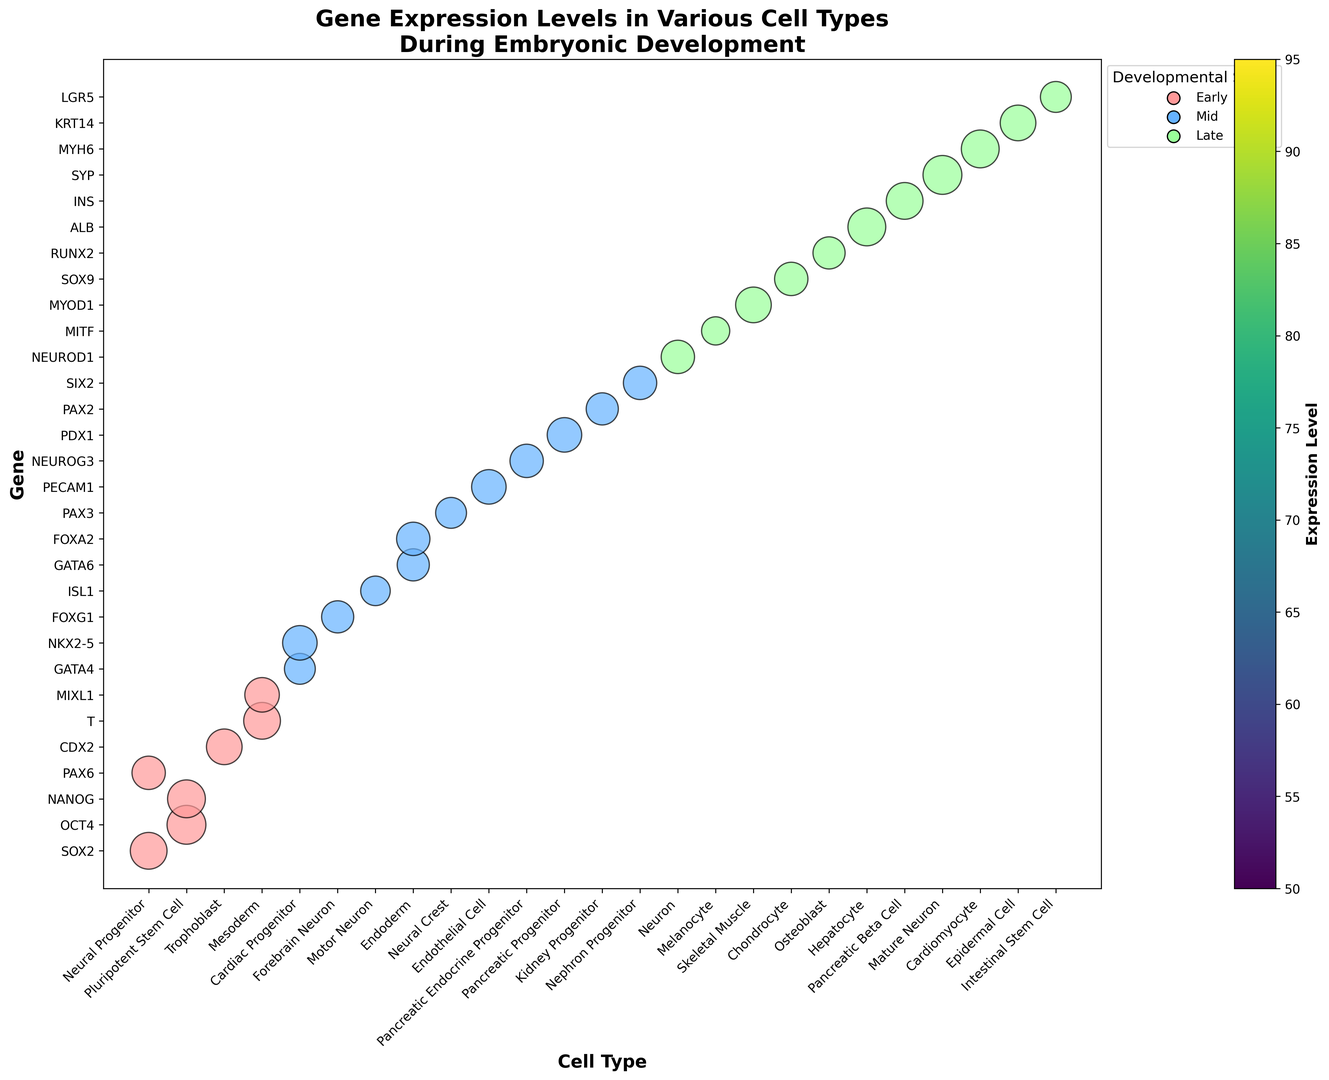How many genes have expression levels greater than 80 during the early developmental stage? First, identify the bubbles colored for the early developmental stage, then count the number of these bubbles with sizes indicating expression levels greater than 80. Genes SOX2, OCT4, NANOG, CDX2, and T satisfy this condition.
Answer: 5 During which developmental stage does the cell type Forebrain Neuron express its gene, and what is the expression level? Find the bubble corresponding to the Forebrain Neuron cell type and note the color and size of the bubble. Forebrain Neuron's gene, FOXG1, is expressed in the mid developmental stage with an expression level size indicating 65.
Answer: Mid, 65 Which gene has the highest expression level during the late developmental stage, and what is that level? Identify the bubbles colored for the late developmental stage and find the one with the largest size. The gene SYP has the highest expression level, indicated by its large bubble size of 95.
Answer: SYP, 95 How does the expression level of OCT4 in the early stage compare to MYOD1 in the late stage? Locate the bubbles for OCT4 and MYOD1, observe their sizes, and compare. OCT4 has an expression level of 95, whereas MYOD1's level is 80, so OCT4 has a higher expression level compared to MYOD1.
Answer: OCT4 is higher What is the difference in expression levels between GATA4 and FOXA2 in the mid stage? Find the bubbles for GATA4 and FOXA2 in the mid stage and note their sizes. GATA4 has an expression level of 60, and FOXA2 has 70. The difference is 70 - 60.
Answer: 10 Identify the cell type with the lowest gene expression level during the late developmental stage and mention the gene. Look for the smallest bubble among those colored for the late stage. The smallest bubble indicates gene MITF in Melanocyte with an expression level of 50.
Answer: Melanocyte, MITF Which cell type has the highest gene expression level in the mid developmental stage and what is the value? Identify the largest bubble colored for the mid developmental stage. The largest bubble corresponds to PDX1 in Pancreatic Progenitor with an expression level of 75.
Answer: Pancreatic Progenitor, 75 What is the average expression level of the genes in the endoderm lineage (GATA6 and FOXA2)? Find the bubbles for GATA6 and FOXA2, note their sizes (65 and 70), add the values, and divide by the number of genes. (65 + 70) / 2 = 67.5
Answer: 67.5 